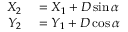<formula> <loc_0><loc_0><loc_500><loc_500>\begin{array} { r l } { X _ { 2 } } & = X _ { 1 } + D \sin \alpha } \\ { Y _ { 2 } } & = Y _ { 1 } + D \cos \alpha } \end{array}</formula> 